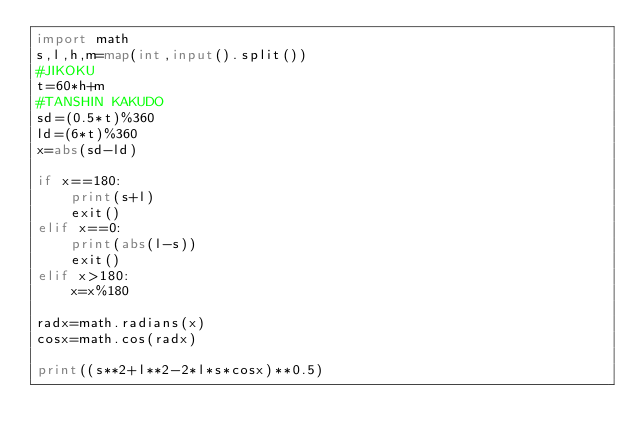<code> <loc_0><loc_0><loc_500><loc_500><_Python_>import math
s,l,h,m=map(int,input().split())
#JIKOKU
t=60*h+m
#TANSHIN KAKUDO
sd=(0.5*t)%360
ld=(6*t)%360
x=abs(sd-ld)

if x==180:
    print(s+l)
    exit()
elif x==0:
    print(abs(l-s))
    exit()
elif x>180:
    x=x%180

radx=math.radians(x)
cosx=math.cos(radx)

print((s**2+l**2-2*l*s*cosx)**0.5)
</code> 